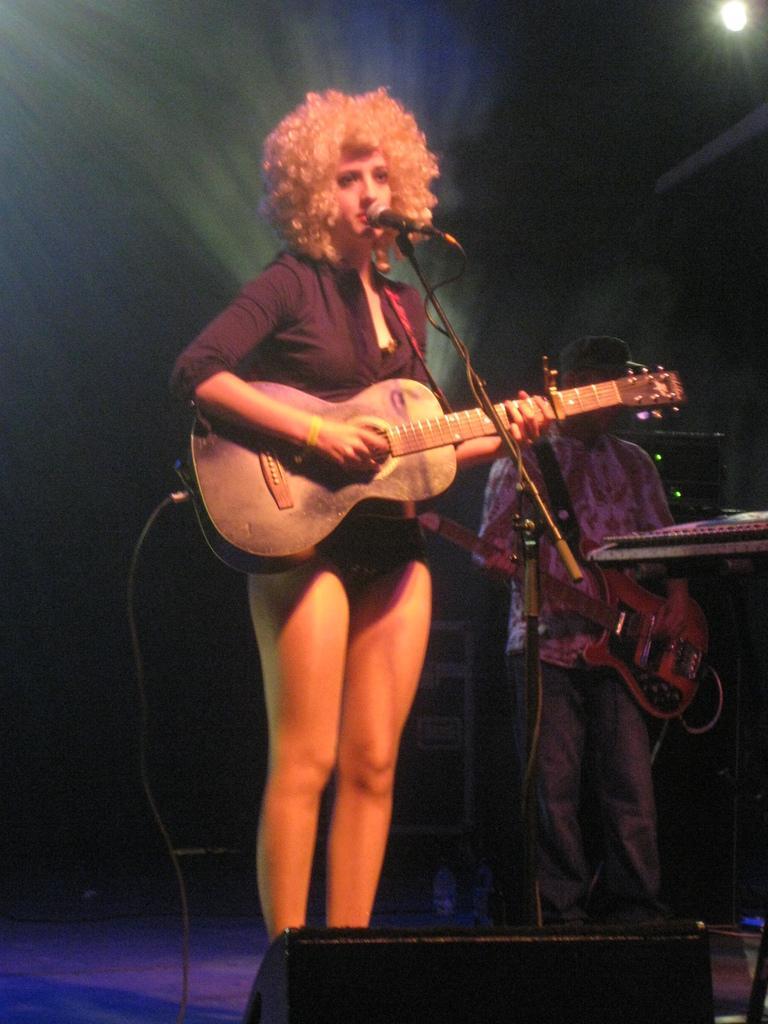Could you give a brief overview of what you see in this image? In this image there is one woman who is standing and she is holding a guitar in front of her there is one mike beside this woman there is another person who is standing and he is holding a guitar. 